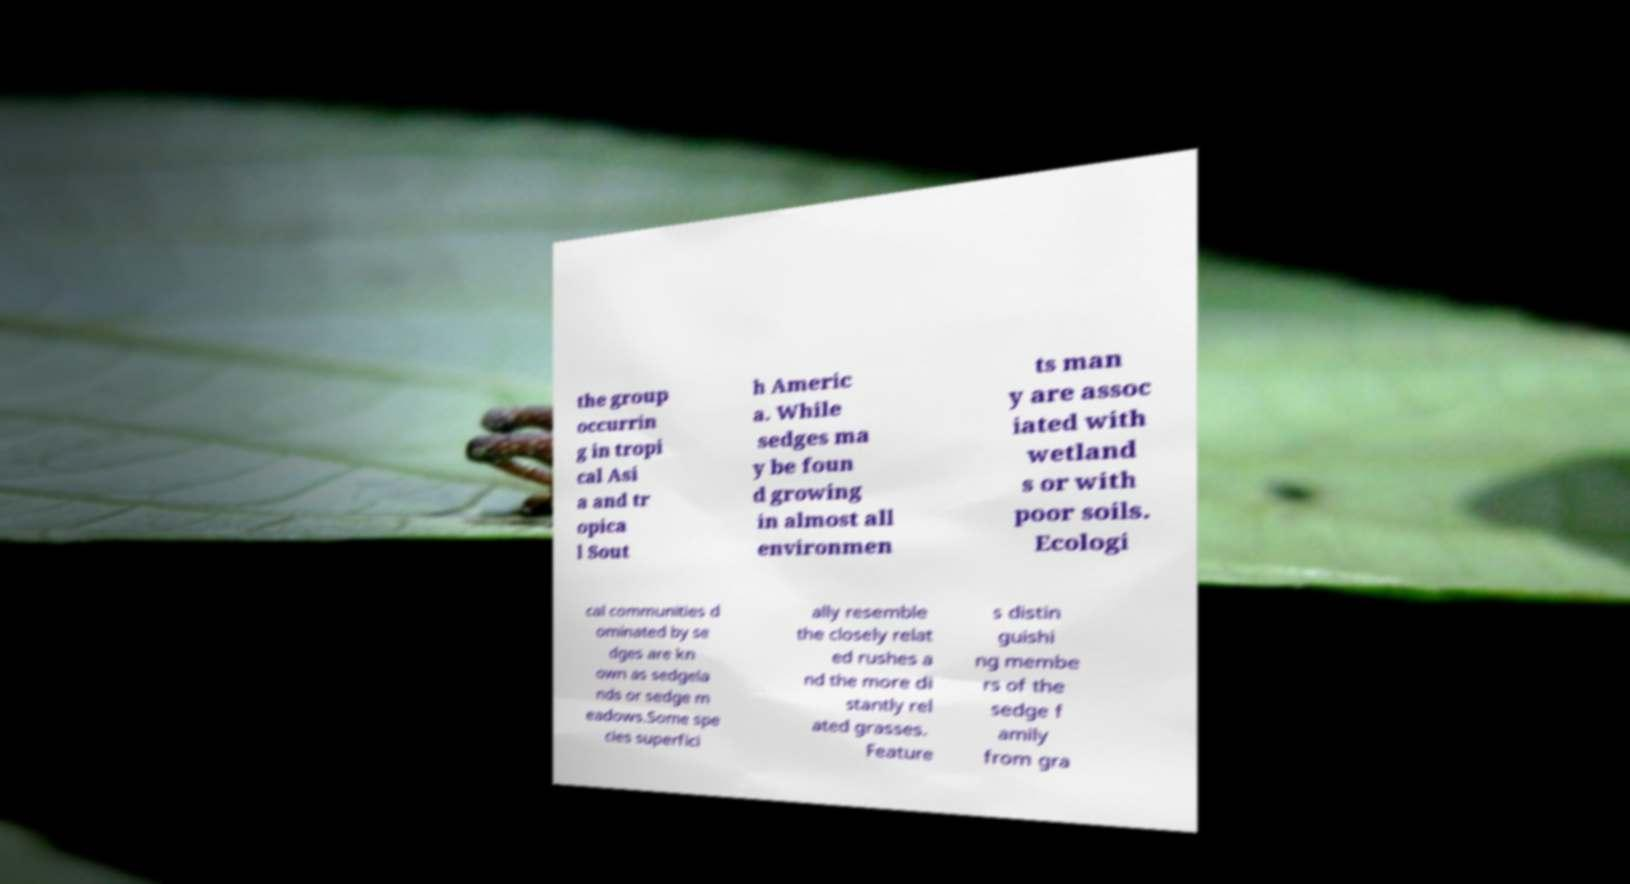What messages or text are displayed in this image? I need them in a readable, typed format. the group occurrin g in tropi cal Asi a and tr opica l Sout h Americ a. While sedges ma y be foun d growing in almost all environmen ts man y are assoc iated with wetland s or with poor soils. Ecologi cal communities d ominated by se dges are kn own as sedgela nds or sedge m eadows.Some spe cies superfici ally resemble the closely relat ed rushes a nd the more di stantly rel ated grasses. Feature s distin guishi ng membe rs of the sedge f amily from gra 